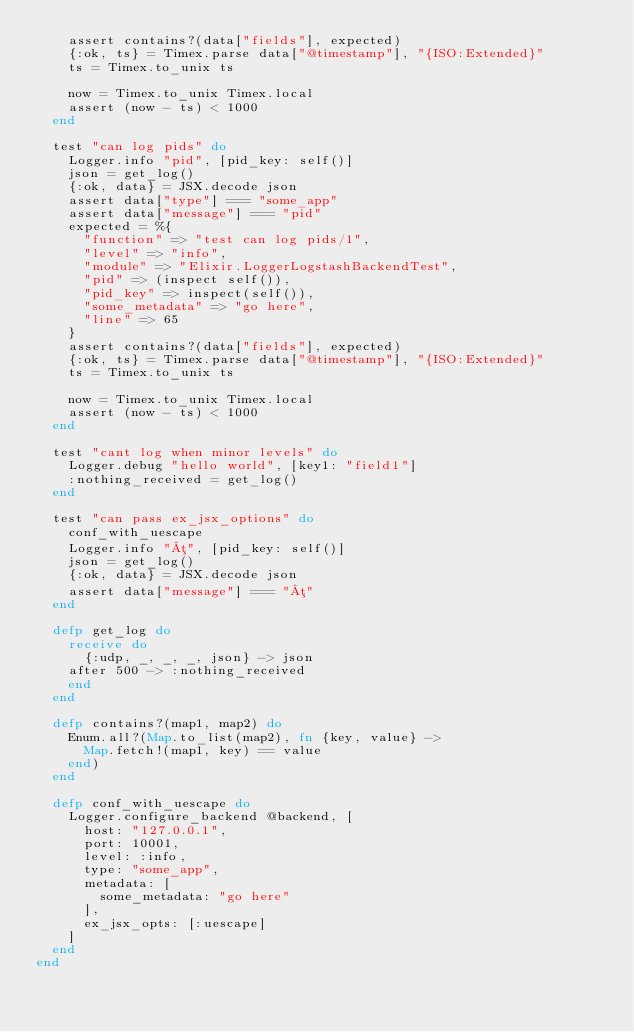<code> <loc_0><loc_0><loc_500><loc_500><_Elixir_>    assert contains?(data["fields"], expected)
    {:ok, ts} = Timex.parse data["@timestamp"], "{ISO:Extended}"
    ts = Timex.to_unix ts

    now = Timex.to_unix Timex.local
    assert (now - ts) < 1000
  end

  test "can log pids" do
    Logger.info "pid", [pid_key: self()]
    json = get_log()
    {:ok, data} = JSX.decode json
    assert data["type"] === "some_app"
    assert data["message"] === "pid"
    expected = %{
      "function" => "test can log pids/1",
      "level" => "info",
      "module" => "Elixir.LoggerLogstashBackendTest",
      "pid" => (inspect self()),
      "pid_key" => inspect(self()),
      "some_metadata" => "go here",
      "line" => 65
    }
    assert contains?(data["fields"], expected)
    {:ok, ts} = Timex.parse data["@timestamp"], "{ISO:Extended}"
    ts = Timex.to_unix ts

    now = Timex.to_unix Timex.local
    assert (now - ts) < 1000
  end

  test "cant log when minor levels" do
    Logger.debug "hello world", [key1: "field1"]
    :nothing_received = get_log()
  end

  test "can pass ex_jsx_options" do
    conf_with_uescape
    Logger.info "µ", [pid_key: self()]
    json = get_log()
    {:ok, data} = JSX.decode json
    assert data["message"] === "µ"
  end

  defp get_log do
    receive do
      {:udp, _, _, _, json} -> json
    after 500 -> :nothing_received
    end
  end

  defp contains?(map1, map2) do
    Enum.all?(Map.to_list(map2), fn {key, value} ->
      Map.fetch!(map1, key) == value
    end)
  end

  defp conf_with_uescape do
    Logger.configure_backend @backend, [
      host: "127.0.0.1",
      port: 10001,
      level: :info,
      type: "some_app",
      metadata: [
        some_metadata: "go here"
      ],
      ex_jsx_opts: [:uescape]
    ]
  end
end
</code> 